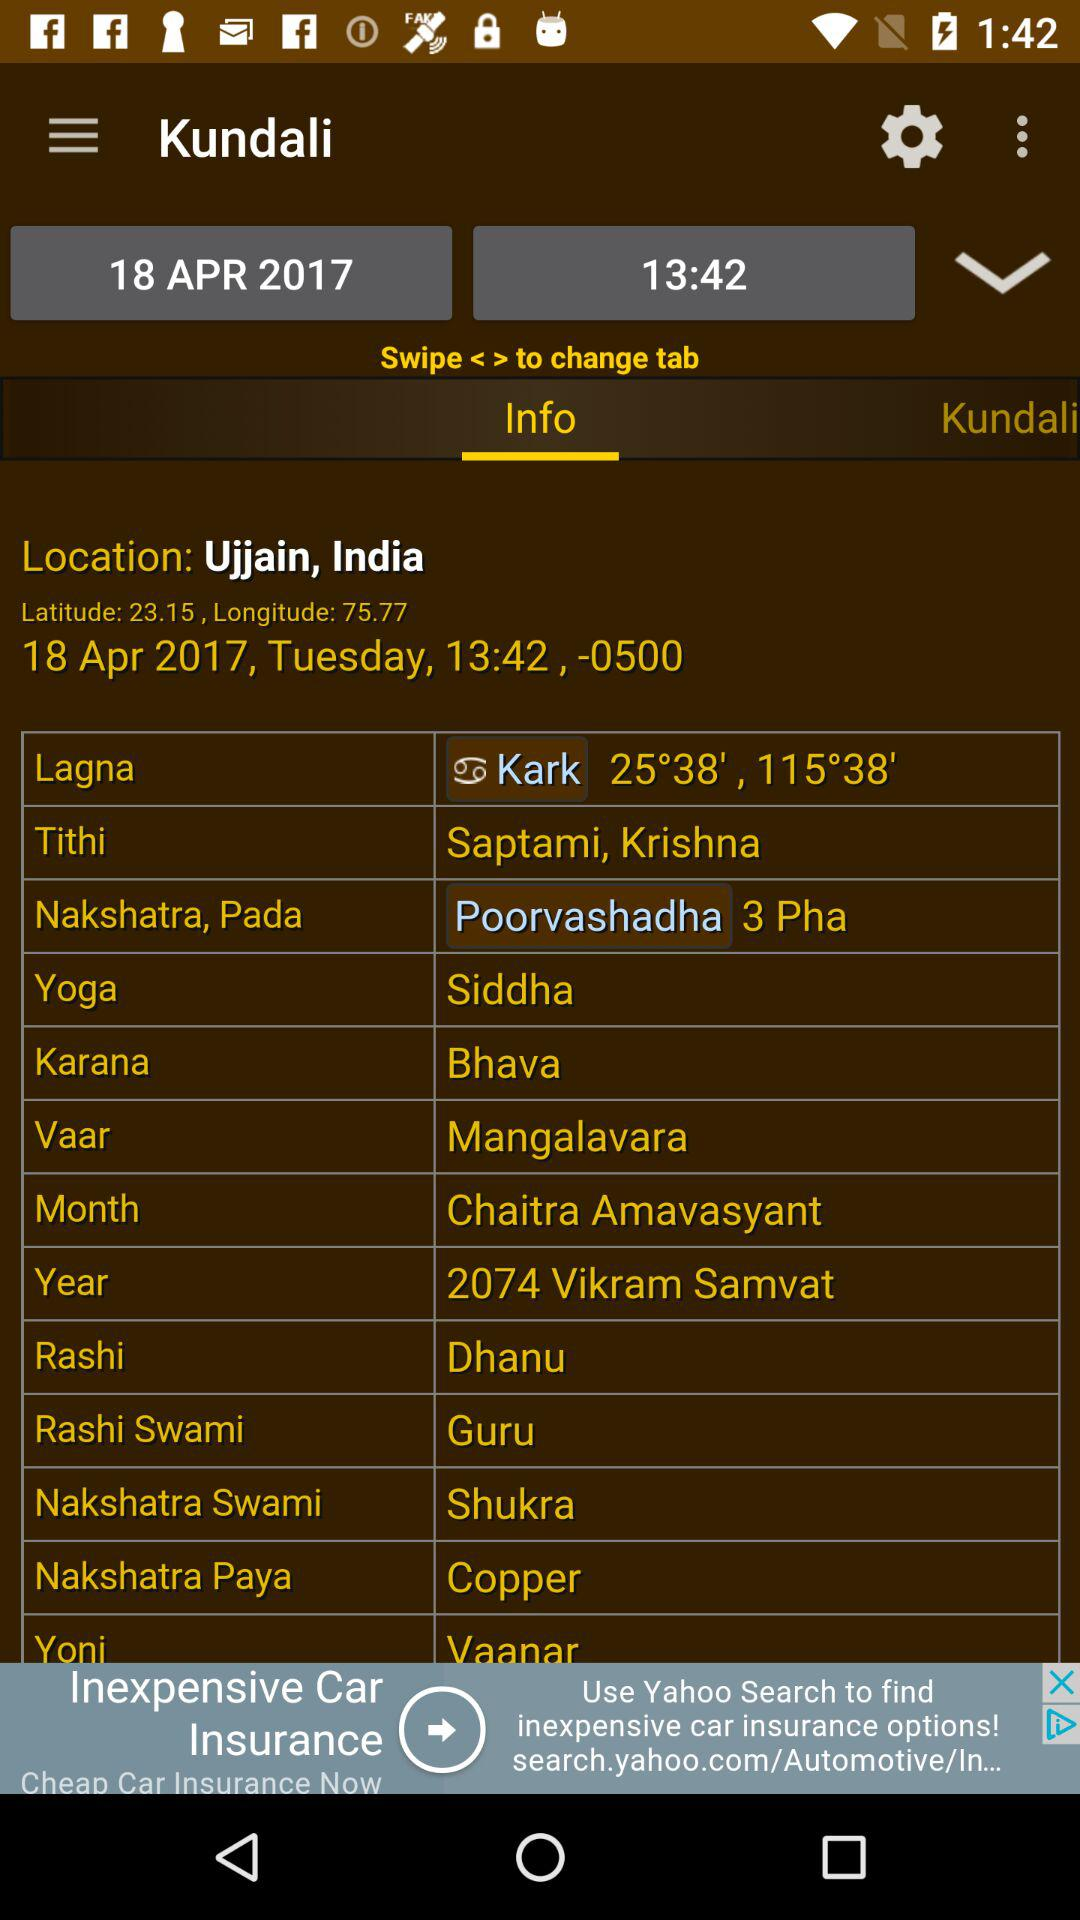What is the rashi? The rashi is Dhanu. 